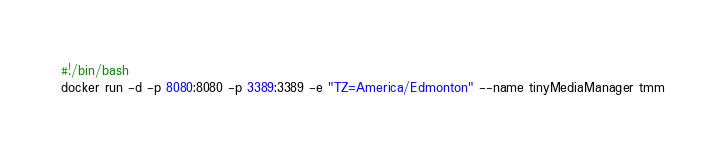<code> <loc_0><loc_0><loc_500><loc_500><_Bash_>#!/bin/bash
docker run -d -p 8080:8080 -p 3389:3389 -e "TZ=America/Edmonton" --name tinyMediaManager tmm

</code> 